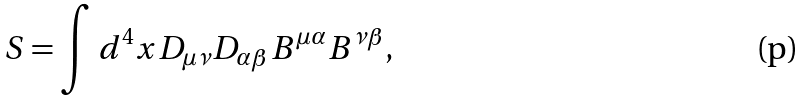<formula> <loc_0><loc_0><loc_500><loc_500>S = \int d ^ { 4 } x D _ { \mu \nu } D _ { \alpha \beta } B ^ { \mu \alpha } B ^ { \nu \beta } ,</formula> 